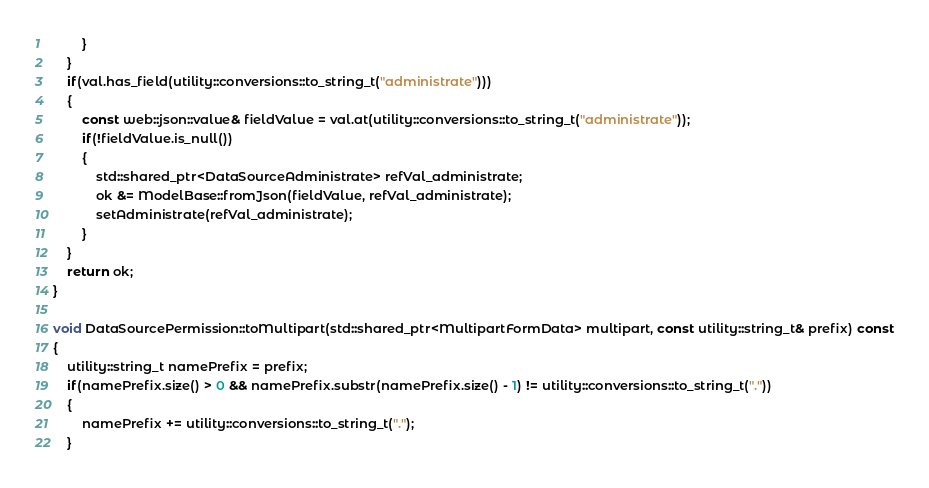Convert code to text. <code><loc_0><loc_0><loc_500><loc_500><_C++_>        }
    }
    if(val.has_field(utility::conversions::to_string_t("administrate")))
    {
        const web::json::value& fieldValue = val.at(utility::conversions::to_string_t("administrate"));
        if(!fieldValue.is_null())
        {
            std::shared_ptr<DataSourceAdministrate> refVal_administrate;
            ok &= ModelBase::fromJson(fieldValue, refVal_administrate);
            setAdministrate(refVal_administrate);
        }
    }
    return ok;
}

void DataSourcePermission::toMultipart(std::shared_ptr<MultipartFormData> multipart, const utility::string_t& prefix) const
{
    utility::string_t namePrefix = prefix;
    if(namePrefix.size() > 0 && namePrefix.substr(namePrefix.size() - 1) != utility::conversions::to_string_t("."))
    {
        namePrefix += utility::conversions::to_string_t(".");
    }</code> 